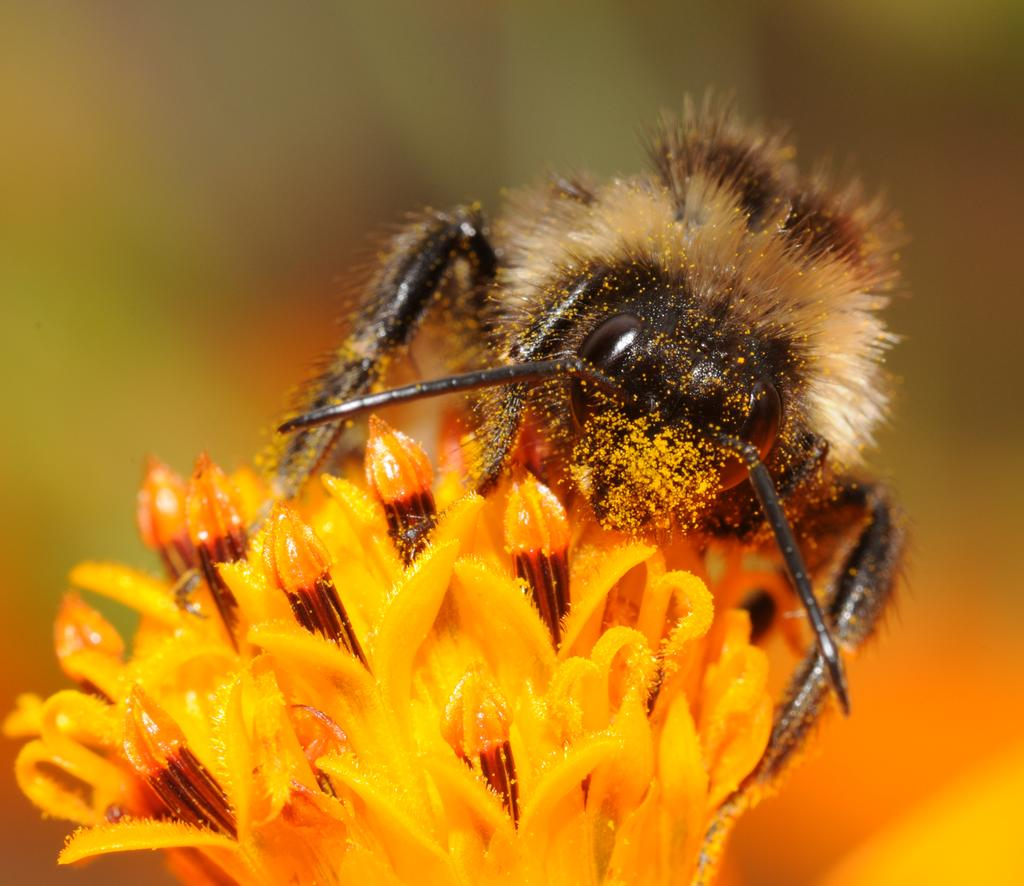What is the main subject of the image? There is a honey bee in the image. What is the honey bee doing in the image? The honey bee is on an orange color flower. Can you describe the background of the image? The background of the image is blurred. What type of cord is attached to the honey bee's father in the image? There is no cord or father of the honey bee present in the image. Honey bees do not have fathers, as they are hatched from unfertilized eggs. 